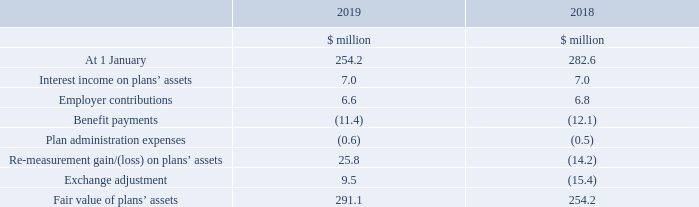9. Pensions continued
Defined benefit plans continued
ii) Amounts in the financial statements continued
e) Movements in the fair value of plans’ assets
What does the table record movements in? The fair value of plans’ assets. What is the fair value of plans' assets in 2019?
Answer scale should be: million. 291.1. In which years are the movements in the fair value of plans' assets recorded? 2019, 2018. In which year were the employer contributions larger? 6.8>6.6
Answer: 2018. What was the change in the fair value of plans' assets?
Answer scale should be: million. 291.1-254.2
Answer: 36.9. What was the percentage change in the fair value of plans' assets?
Answer scale should be: percent. (291.1-254.2)/254.2
Answer: 14.52. 